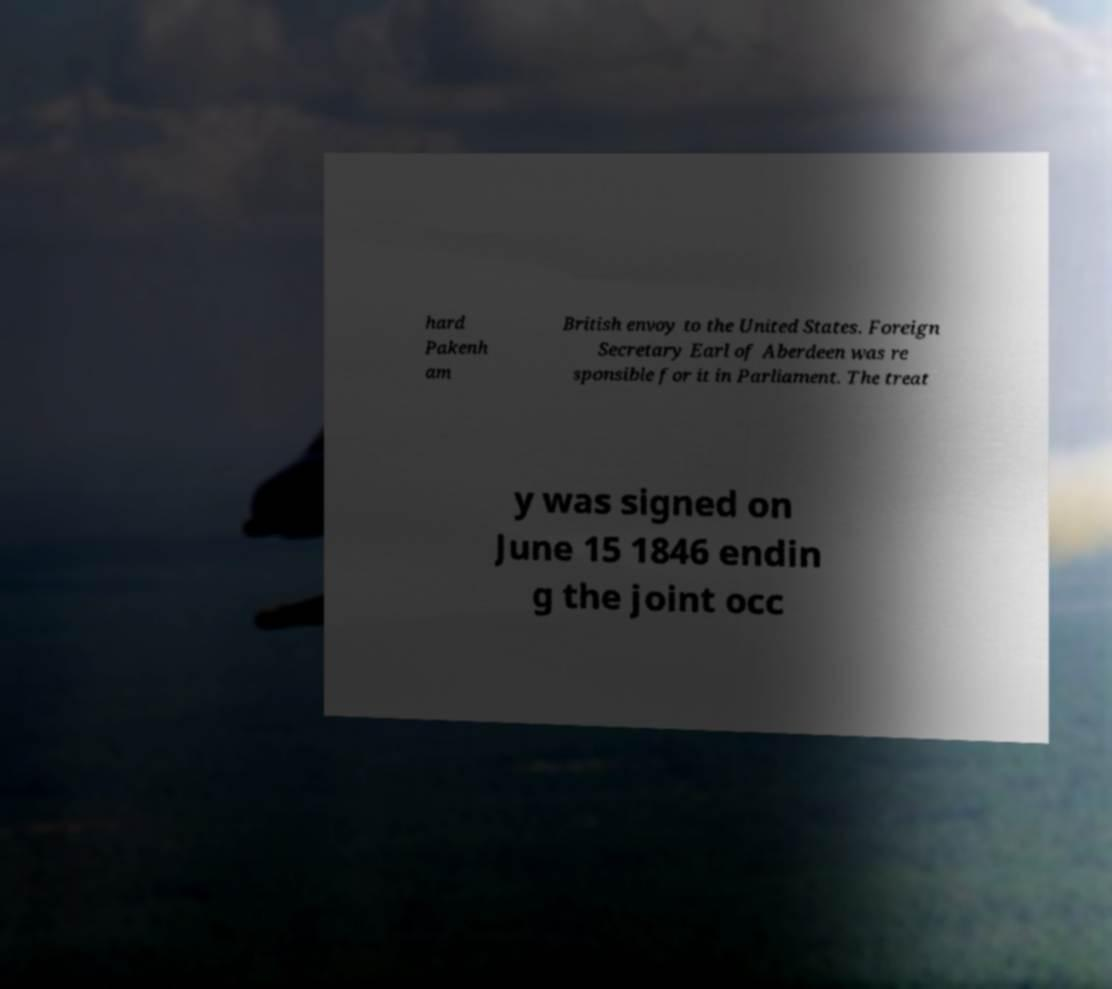Please identify and transcribe the text found in this image. hard Pakenh am British envoy to the United States. Foreign Secretary Earl of Aberdeen was re sponsible for it in Parliament. The treat y was signed on June 15 1846 endin g the joint occ 